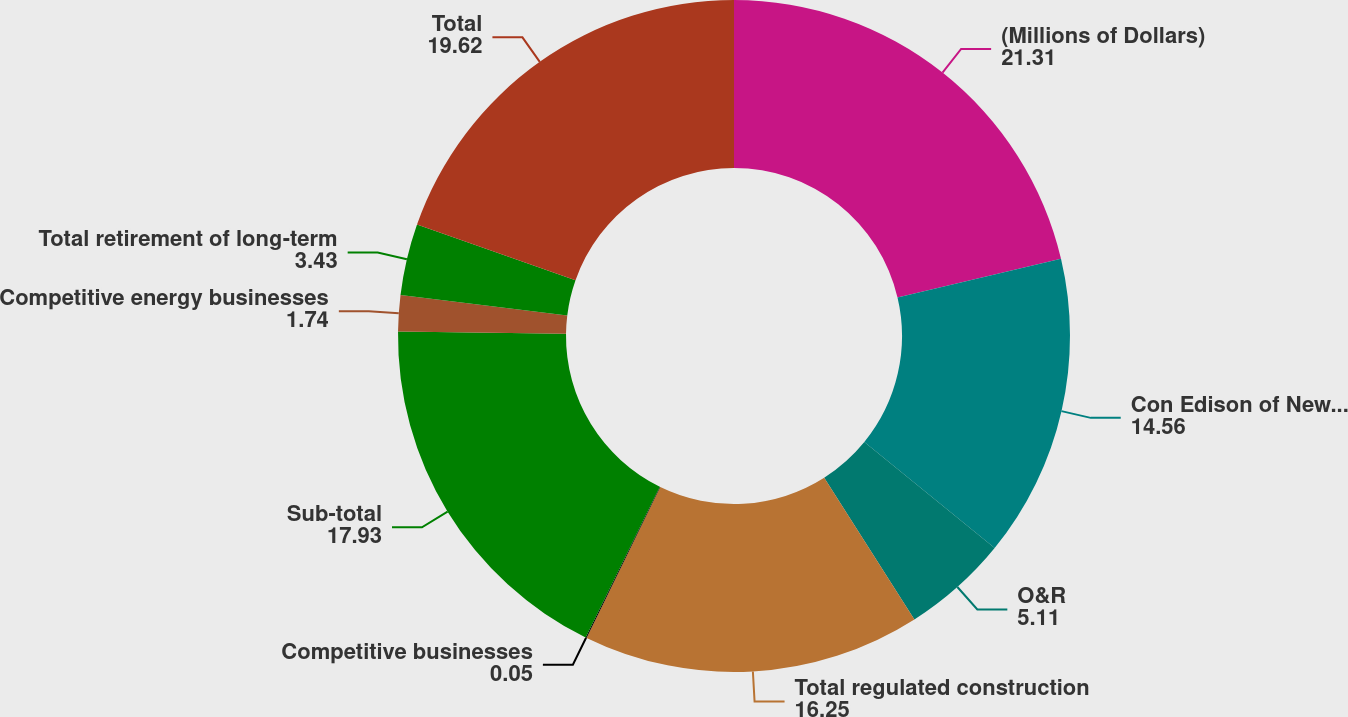<chart> <loc_0><loc_0><loc_500><loc_500><pie_chart><fcel>(Millions of Dollars)<fcel>Con Edison of New York<fcel>O&R<fcel>Total regulated construction<fcel>Competitive businesses<fcel>Sub-total<fcel>Competitive energy businesses<fcel>Total retirement of long-term<fcel>Total<nl><fcel>21.31%<fcel>14.56%<fcel>5.11%<fcel>16.25%<fcel>0.05%<fcel>17.93%<fcel>1.74%<fcel>3.43%<fcel>19.62%<nl></chart> 